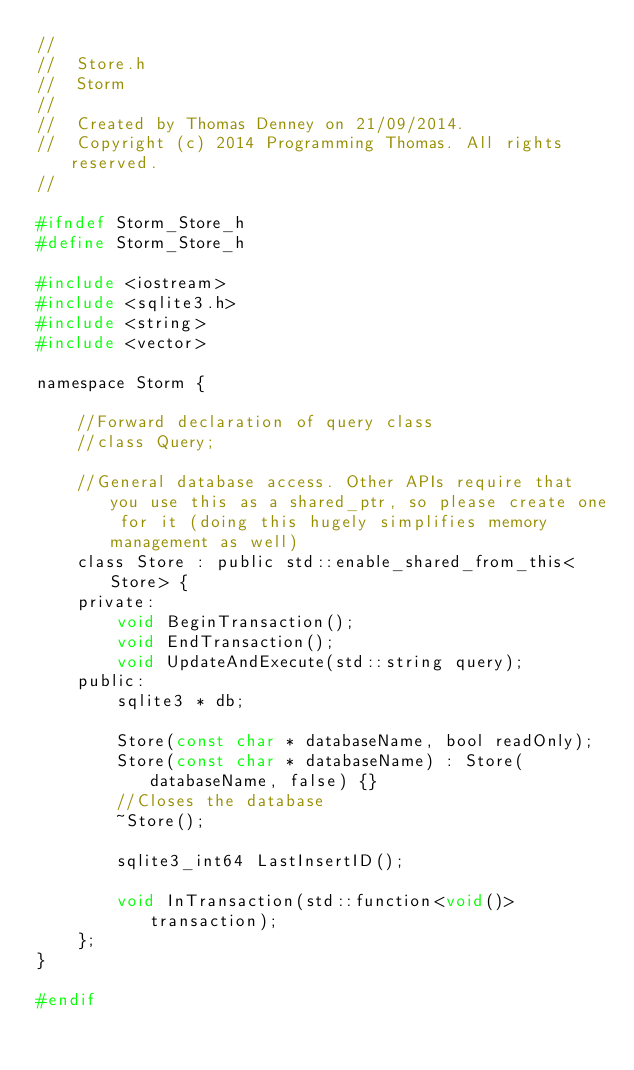<code> <loc_0><loc_0><loc_500><loc_500><_C_>//
//  Store.h
//  Storm
//
//  Created by Thomas Denney on 21/09/2014.
//  Copyright (c) 2014 Programming Thomas. All rights reserved.
//

#ifndef Storm_Store_h
#define Storm_Store_h

#include <iostream>
#include <sqlite3.h>
#include <string>
#include <vector>

namespace Storm {

    //Forward declaration of query class
    //class Query;

    //General database access. Other APIs require that you use this as a shared_ptr, so please create one for it (doing this hugely simplifies memory management as well)
    class Store : public std::enable_shared_from_this<Store> {
    private:
        void BeginTransaction();
        void EndTransaction();
        void UpdateAndExecute(std::string query);
    public:
        sqlite3 * db;

        Store(const char * databaseName, bool readOnly);
        Store(const char * databaseName) : Store(databaseName, false) {}
        //Closes the database
        ~Store();

        sqlite3_int64 LastInsertID();

        void InTransaction(std::function<void()> transaction);
    };
}

#endif
</code> 